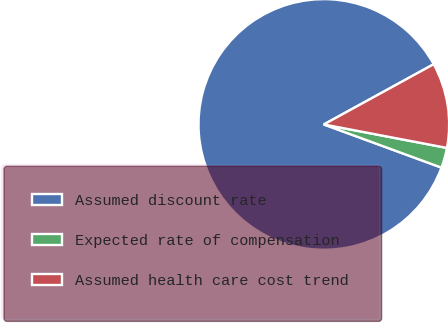<chart> <loc_0><loc_0><loc_500><loc_500><pie_chart><fcel>Assumed discount rate<fcel>Expected rate of compensation<fcel>Assumed health care cost trend<nl><fcel>86.42%<fcel>2.6%<fcel>10.98%<nl></chart> 